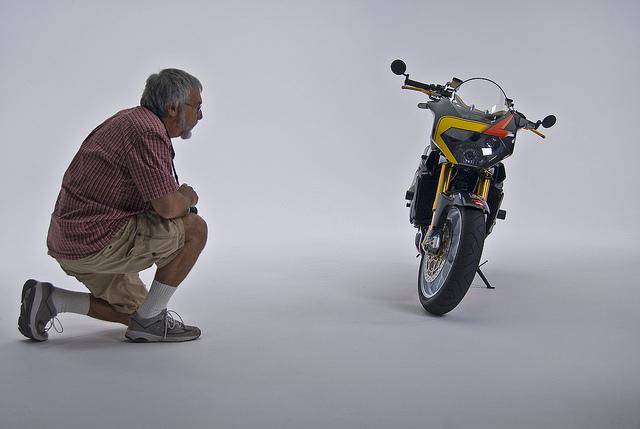IS the man standing?
Be succinct. No. Is this person moving?
Write a very short answer. No. Is the man topless?
Write a very short answer. No. What is the man wearing?
Give a very brief answer. Shorts. What kind of shoes is the man wearing?
Write a very short answer. Tennis shoes. Could the man knock over the motorcycle?
Write a very short answer. Yes. Is the motorcycle equipped for long distance travel?
Write a very short answer. No. What is the man doing?
Quick response, please. Kneeling. What color is the motorcycle?
Be succinct. Yellow. What is the man looking at?
Short answer required. Motorcycle. 